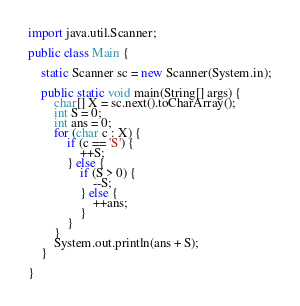Convert code to text. <code><loc_0><loc_0><loc_500><loc_500><_Java_>import java.util.Scanner;

public class Main {

	static Scanner sc = new Scanner(System.in);

	public static void main(String[] args) {
		char[] X = sc.next().toCharArray();
		int S = 0;
		int ans = 0;
		for (char c : X) {
			if (c == 'S') {
				++S;
			} else {
				if (S > 0) {
					--S;
				} else {
					++ans;
				}
			}
		}
		System.out.println(ans + S);
	}

}
</code> 